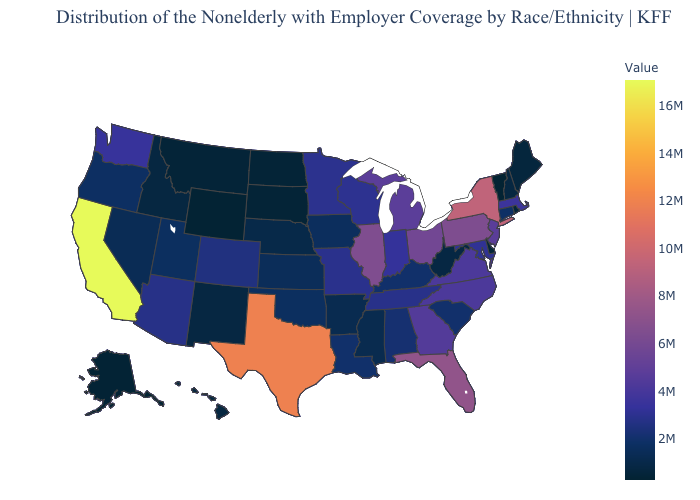Does the map have missing data?
Be succinct. No. Among the states that border Texas , which have the lowest value?
Keep it brief. New Mexico. Which states have the lowest value in the USA?
Give a very brief answer. Vermont. Does Oregon have a higher value than New Jersey?
Be succinct. No. 